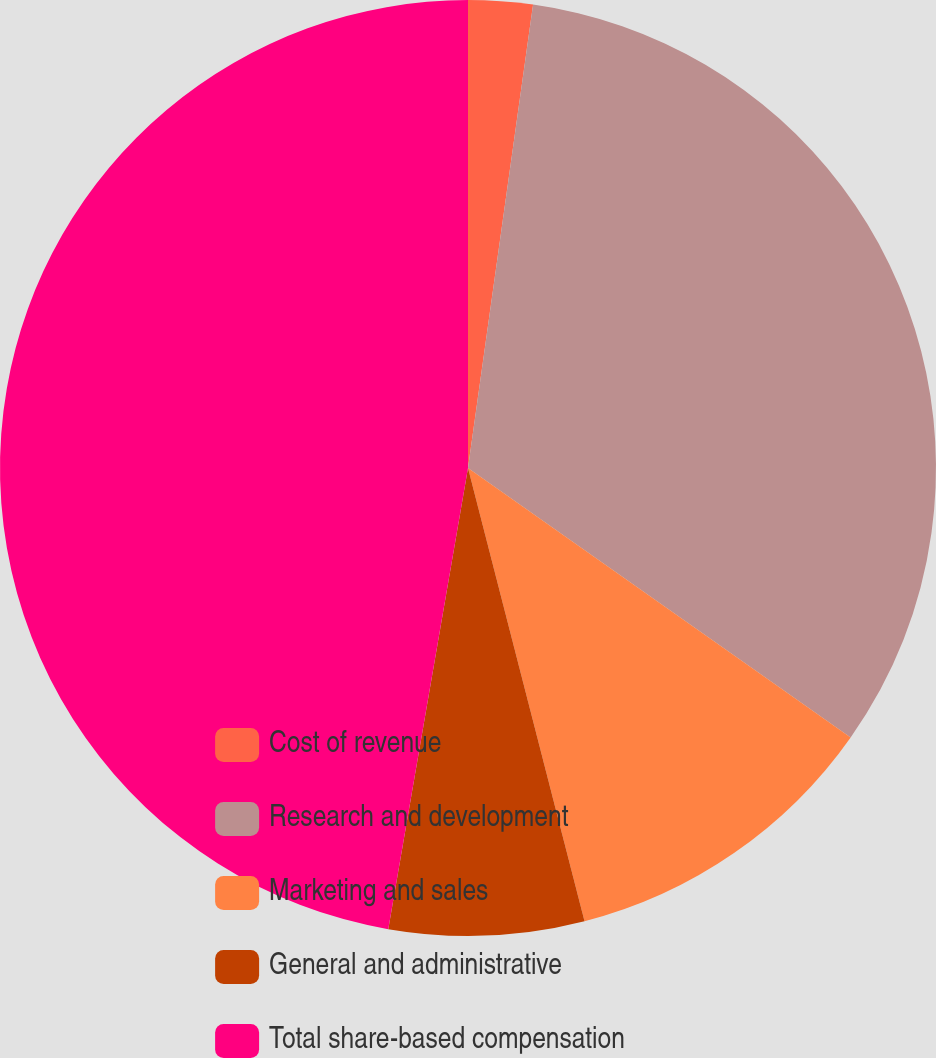Convert chart to OTSL. <chart><loc_0><loc_0><loc_500><loc_500><pie_chart><fcel>Cost of revenue<fcel>Research and development<fcel>Marketing and sales<fcel>General and administrative<fcel>Total share-based compensation<nl><fcel>2.22%<fcel>32.54%<fcel>11.23%<fcel>6.73%<fcel>47.27%<nl></chart> 